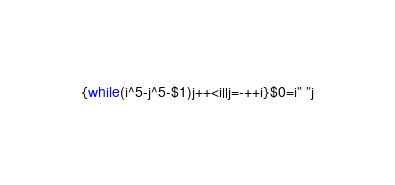<code> <loc_0><loc_0><loc_500><loc_500><_Awk_>{while(i^5-j^5-$1)j++<i||j=-++i}$0=i" "j</code> 